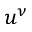Convert formula to latex. <formula><loc_0><loc_0><loc_500><loc_500>u ^ { \nu }</formula> 